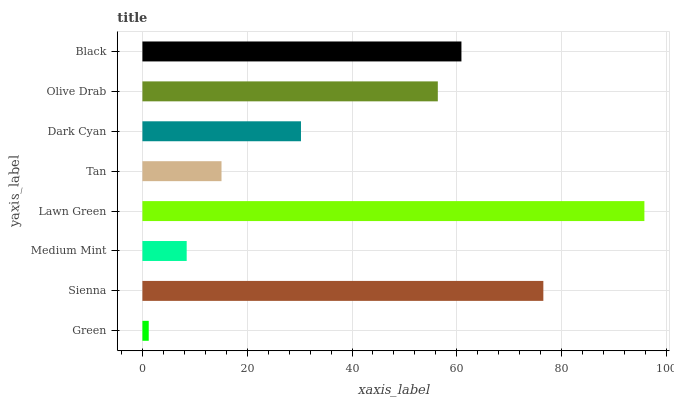Is Green the minimum?
Answer yes or no. Yes. Is Lawn Green the maximum?
Answer yes or no. Yes. Is Sienna the minimum?
Answer yes or no. No. Is Sienna the maximum?
Answer yes or no. No. Is Sienna greater than Green?
Answer yes or no. Yes. Is Green less than Sienna?
Answer yes or no. Yes. Is Green greater than Sienna?
Answer yes or no. No. Is Sienna less than Green?
Answer yes or no. No. Is Olive Drab the high median?
Answer yes or no. Yes. Is Dark Cyan the low median?
Answer yes or no. Yes. Is Green the high median?
Answer yes or no. No. Is Lawn Green the low median?
Answer yes or no. No. 